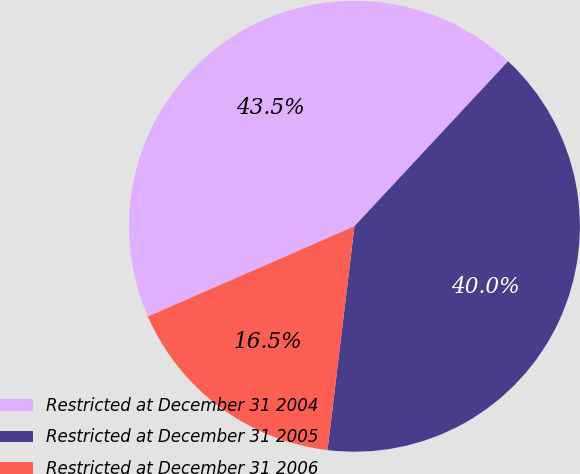Convert chart. <chart><loc_0><loc_0><loc_500><loc_500><pie_chart><fcel>Restricted at December 31 2004<fcel>Restricted at December 31 2005<fcel>Restricted at December 31 2006<nl><fcel>43.49%<fcel>39.97%<fcel>16.54%<nl></chart> 